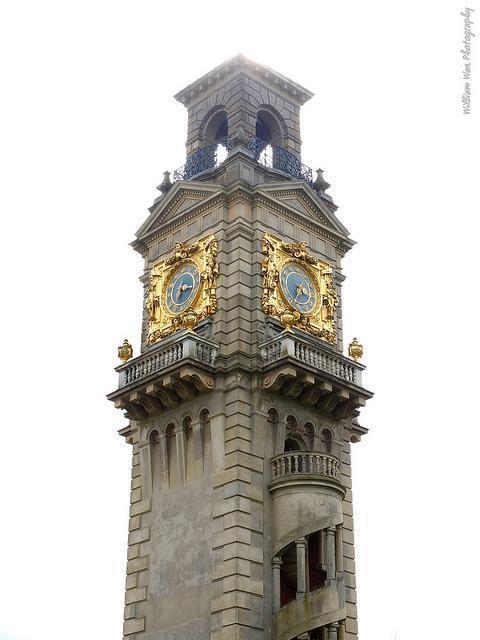How many people are wearing white shirt?
Give a very brief answer. 0. 